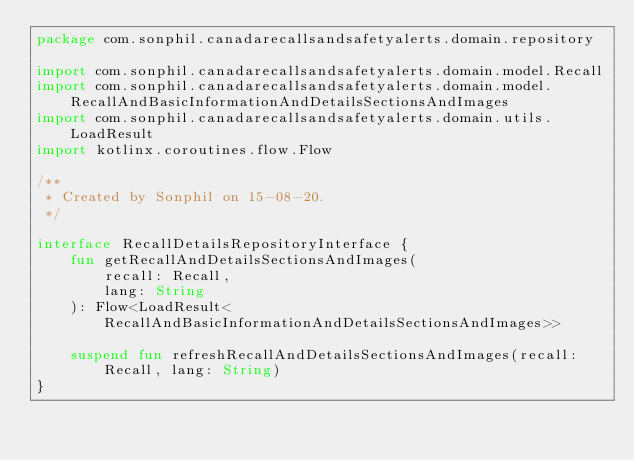Convert code to text. <code><loc_0><loc_0><loc_500><loc_500><_Kotlin_>package com.sonphil.canadarecallsandsafetyalerts.domain.repository

import com.sonphil.canadarecallsandsafetyalerts.domain.model.Recall
import com.sonphil.canadarecallsandsafetyalerts.domain.model.RecallAndBasicInformationAndDetailsSectionsAndImages
import com.sonphil.canadarecallsandsafetyalerts.domain.utils.LoadResult
import kotlinx.coroutines.flow.Flow

/**
 * Created by Sonphil on 15-08-20.
 */

interface RecallDetailsRepositoryInterface {
    fun getRecallAndDetailsSectionsAndImages(
        recall: Recall,
        lang: String
    ): Flow<LoadResult<RecallAndBasicInformationAndDetailsSectionsAndImages>>

    suspend fun refreshRecallAndDetailsSectionsAndImages(recall: Recall, lang: String)
}
</code> 